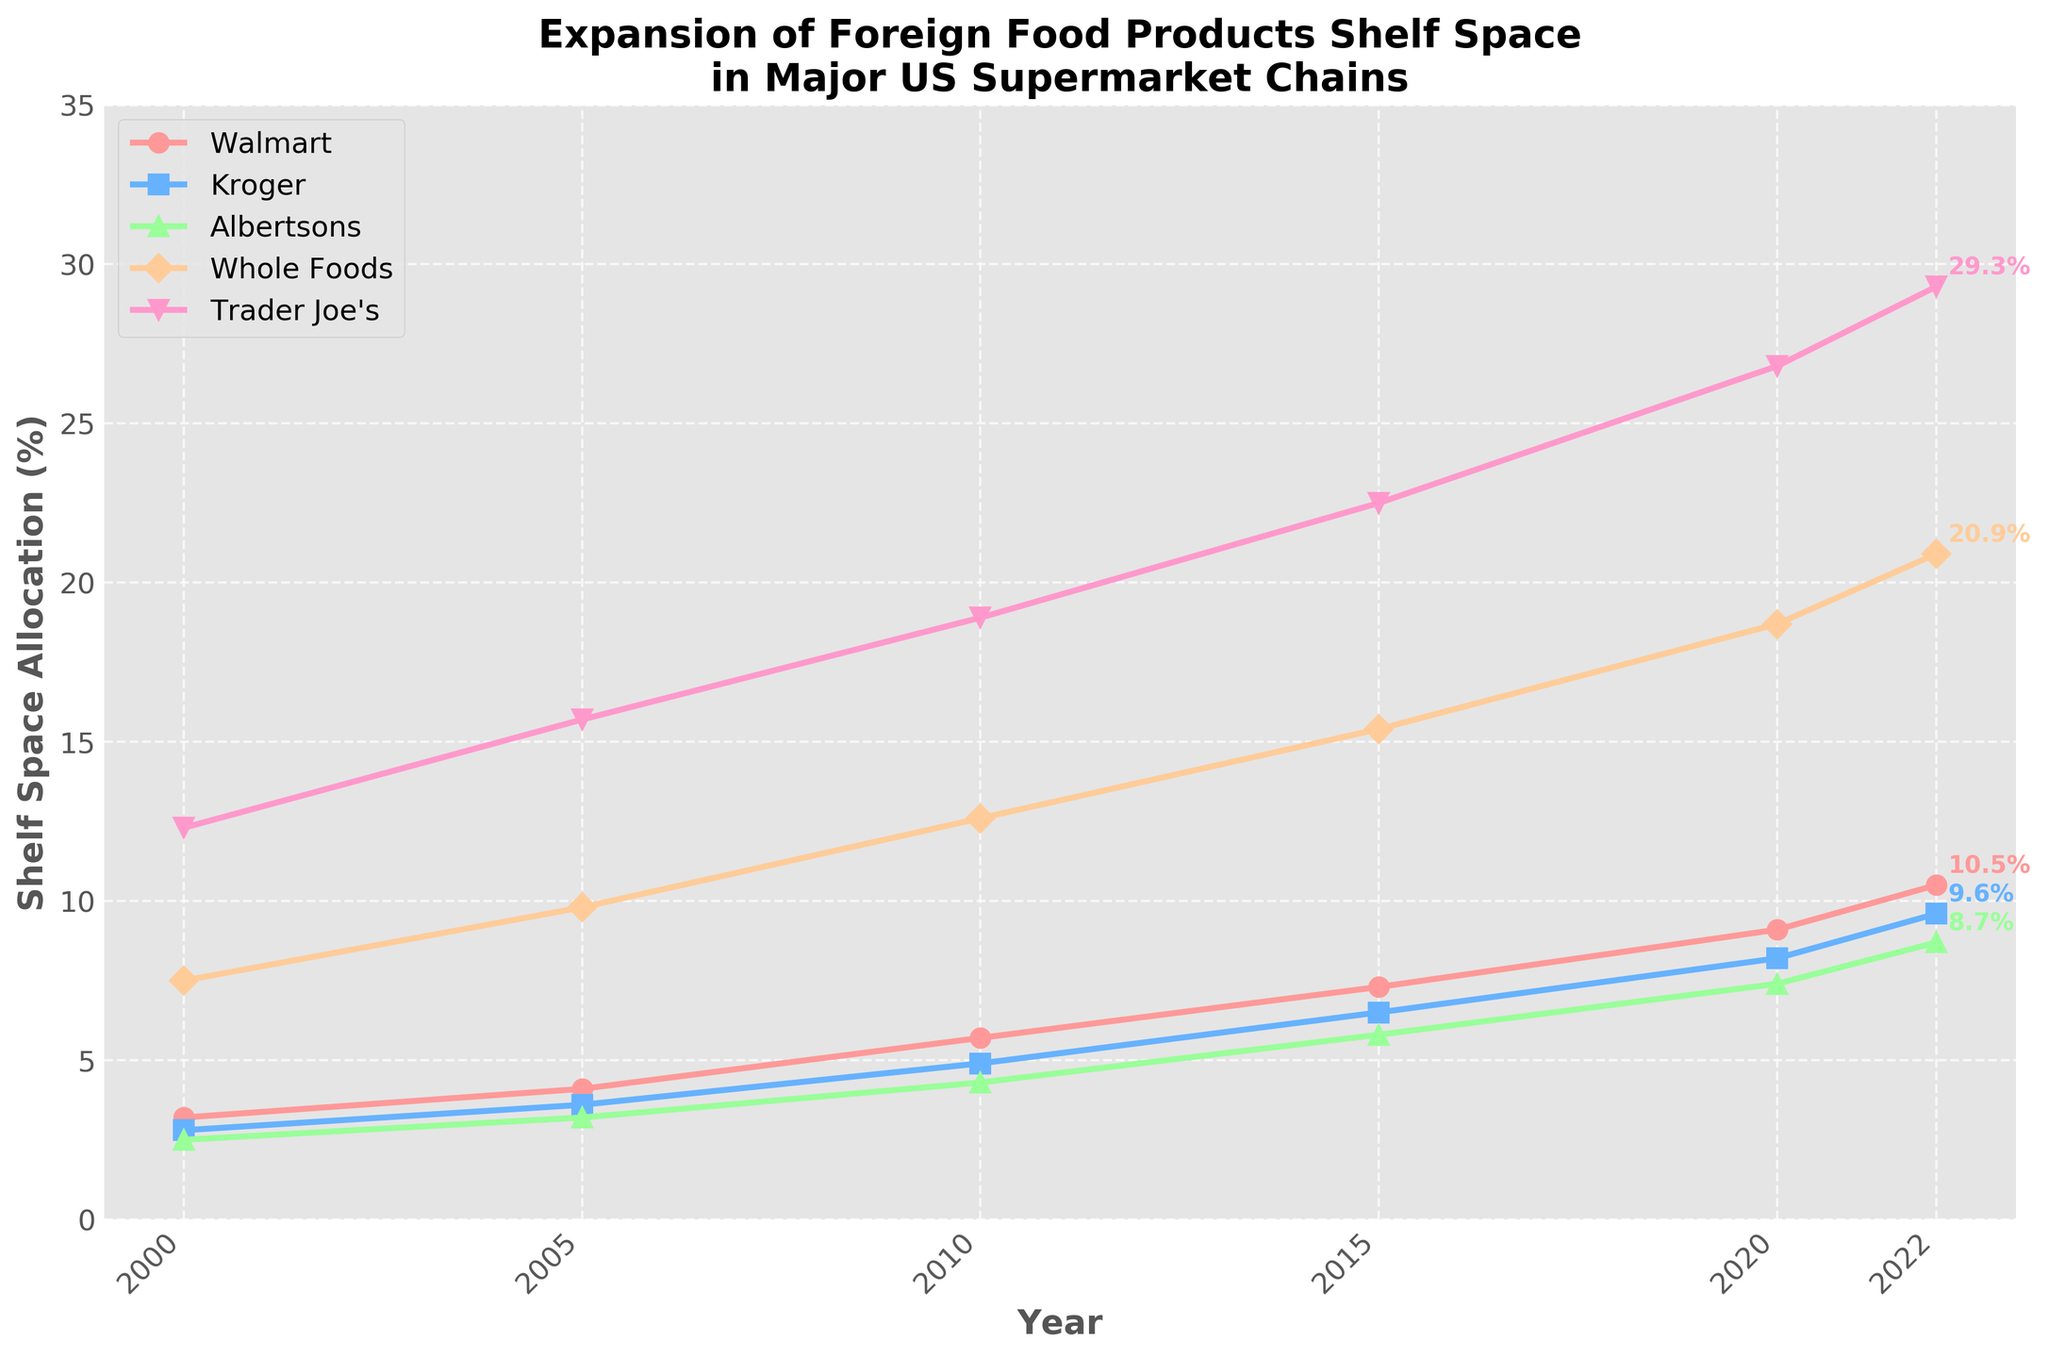What is the general trend for shelf space allocated to foreign food products from 2000 to 2022? Over the years from 2000 to 2022, all supermarket chains (Walmart, Kroger, Albertsons, Whole Foods, Trader Joe's) show an upward trend in the percentage of shelf space allocated to foreign food products. This is evident as all the lines in the plot show an increase over the years.
Answer: Upward trend Which supermarket had the highest shelf space allocation in 2022? In 2022, among the listed supermarket chains, Trader Joe's had the highest percentage of shelf space allocated to foreign food products, as indicated by the line positioned highest on the chart at that year.
Answer: Trader Joe's How much did the shelf space for foreign foods at Whole Foods increase from 2000 to 2022? In 2000, Whole Foods allocated 7.5% of shelf space to foreign food products, and by 2022, this increased to 20.9%. The increase is calculated as 20.9% - 7.5%.
Answer: 13.4% In which year did Albertsons’ shelf space allocation surpass 5%? Observing the line for Albertsons, in 2015, the shelf space allocation is marked at 5.8%, and before 2015, it was below 5%.
Answer: 2015 Comparing Kroger and Walmart, in which year did Walmart first have more shelf space allocated to foreign foods than Kroger? Looking at the lines for Walmart and Kroger, in 2005, Walmart's shelf space allocation (4.1%) exceeded Kroger’s (3.6%) for the first time.
Answer: 2005 What is the difference in shelf space allocated to foreign foods between Trader Joe’s and Walmart in 2020? In 2020, Trader Joe's allocated 26.8% and Walmart allocated 9.1% of their shelf space to foreign foods. The difference is 26.8% - 9.1%.
Answer: 17.7% Which supermarket showed the most significant increase in shelf space allocation from 2010 to 2022? To find this, we calculate the difference for each supermarket from 2010 to 2022. Trader Joe’s increased from 18.9% to 29.3%, which is an increase of 10.4%, the largest among all the supermarkets.
Answer: Trader Joe's Has Kroger’s allocation been increasing at a consistent rate throughout the years? Observing the line for Kroger, it shows a consistent and steady increase each year without any sharp dips or plateaus, indicating a consistent increase.
Answer: Yes Between 2005 and 2015, which supermarket had a steeper rise in the allocation of foreign foods, Kroger or Whole Foods? To determine this, calculate the rise for each supermarket over the period: Kroger increased from 3.6% (2005) to 6.5% (2015), a rise of 2.9%. Whole Foods increased from 9.8% (2005) to 15.4% (2015), a rise of 5.6%. Therefore, Whole Foods had a steeper rise.
Answer: Whole Foods 